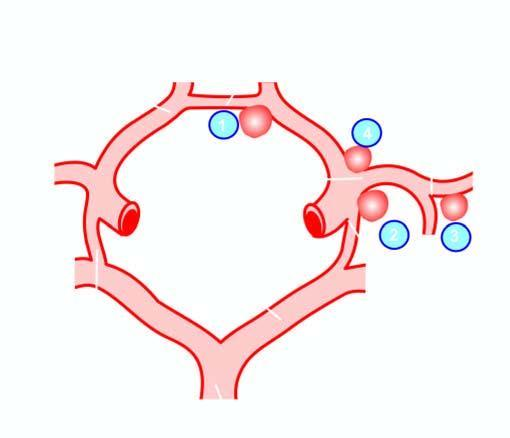what do the serial numbers indicate?
Answer the question using a single word or phrase. Frequency of involvement 